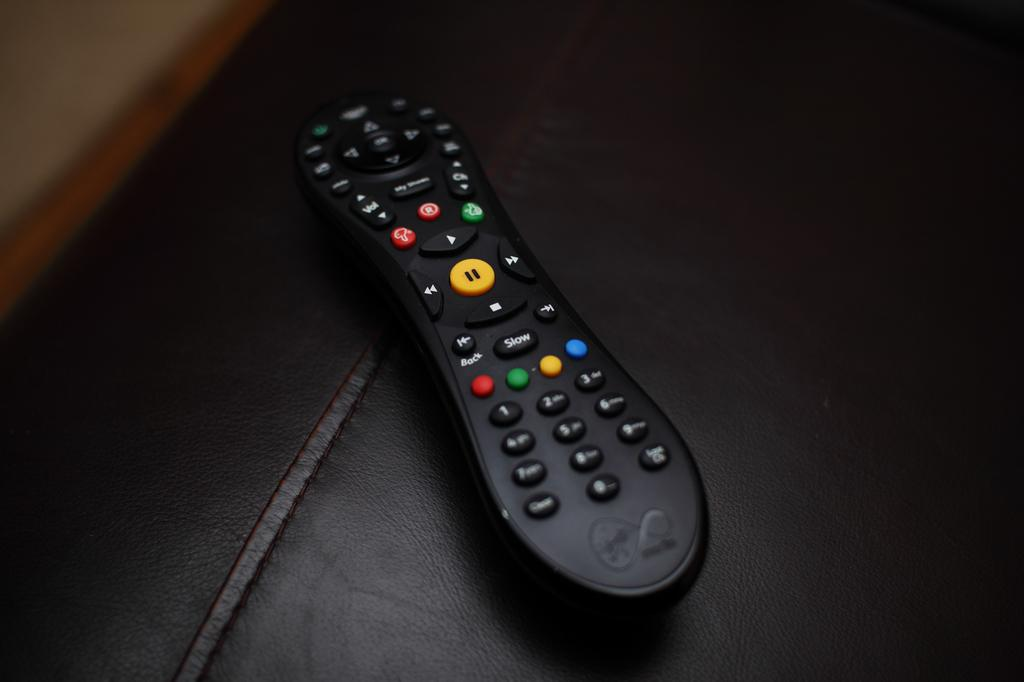<image>
Describe the image concisely. A black remote with a button that says Slow is sitting a black leather couch. 